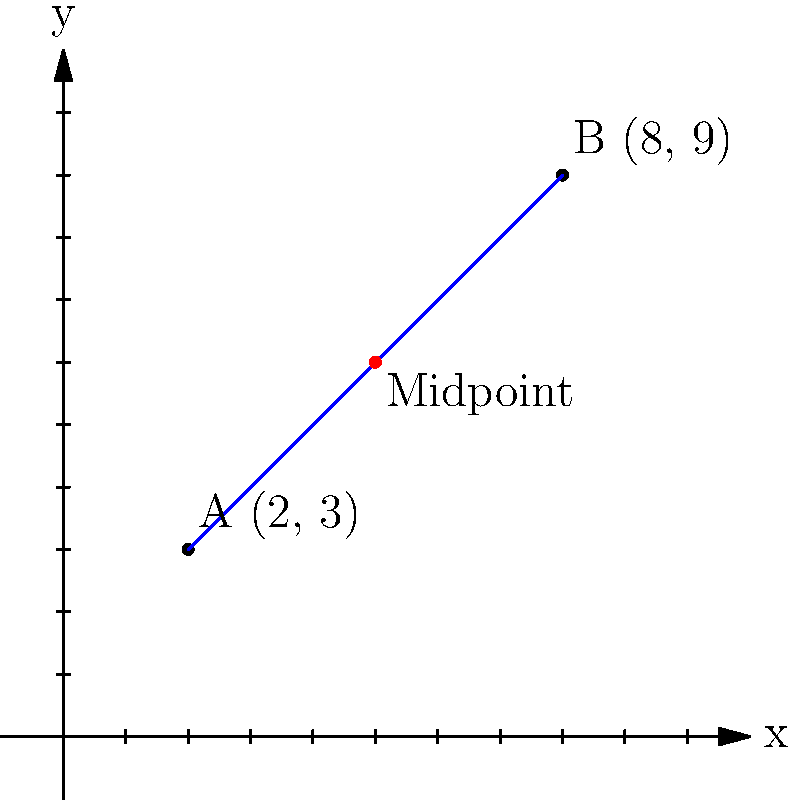Two popular attractions at our festival are located at coordinates A(2, 3) and B(8, 9). To improve visitor experience, we want to place an information booth at the midpoint between these attractions. Calculate the coordinates of this midpoint where the booth should be placed. To find the midpoint between two points, we use the midpoint formula:

Midpoint = $(\frac{x_1 + x_2}{2}, \frac{y_1 + y_2}{2})$

Where $(x_1, y_1)$ are the coordinates of the first point and $(x_2, y_2)$ are the coordinates of the second point.

Given:
- Point A: (2, 3)
- Point B: (8, 9)

Step 1: Calculate the x-coordinate of the midpoint
$x_{midpoint} = \frac{x_1 + x_2}{2} = \frac{2 + 8}{2} = \frac{10}{2} = 5$

Step 2: Calculate the y-coordinate of the midpoint
$y_{midpoint} = \frac{y_1 + y_2}{2} = \frac{3 + 9}{2} = \frac{12}{2} = 6$

Therefore, the coordinates of the midpoint are (5, 6).
Answer: (5, 6) 